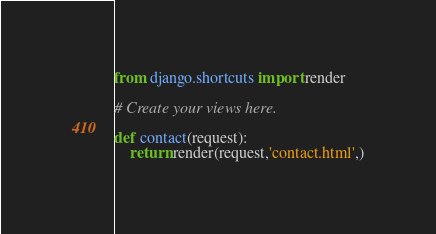<code> <loc_0><loc_0><loc_500><loc_500><_Python_>from django.shortcuts import render

# Create your views here.

def contact(request):
    return render(request,'contact.html',)</code> 